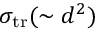Convert formula to latex. <formula><loc_0><loc_0><loc_500><loc_500>\sigma _ { t r } ( \sim d ^ { 2 } )</formula> 